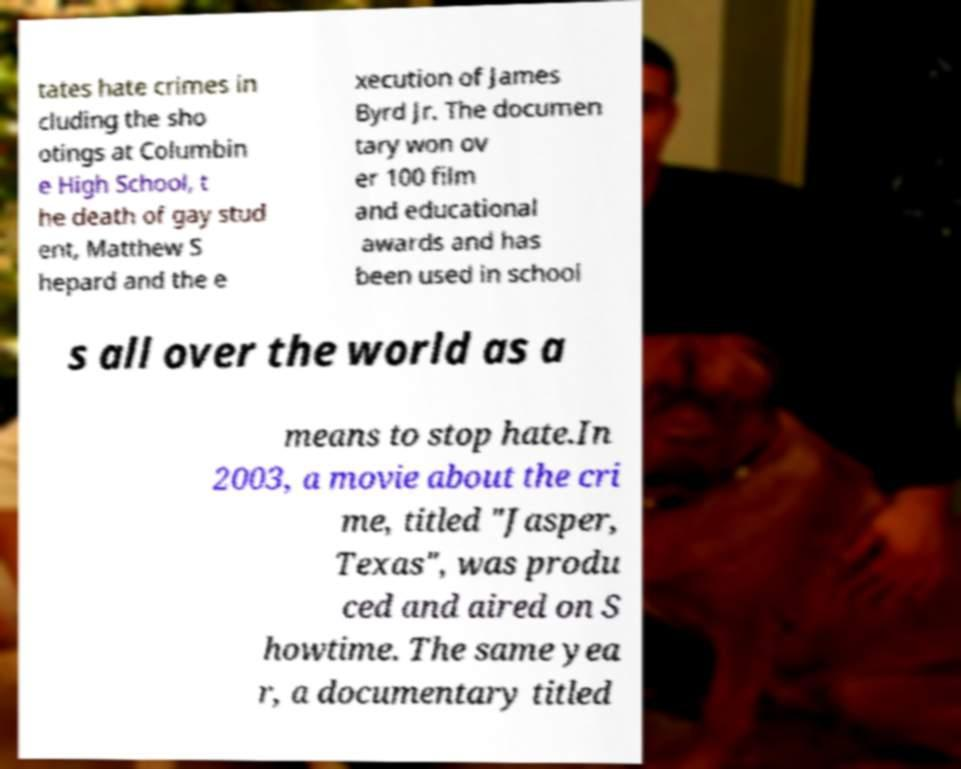There's text embedded in this image that I need extracted. Can you transcribe it verbatim? tates hate crimes in cluding the sho otings at Columbin e High School, t he death of gay stud ent, Matthew S hepard and the e xecution of James Byrd Jr. The documen tary won ov er 100 film and educational awards and has been used in school s all over the world as a means to stop hate.In 2003, a movie about the cri me, titled "Jasper, Texas", was produ ced and aired on S howtime. The same yea r, a documentary titled 